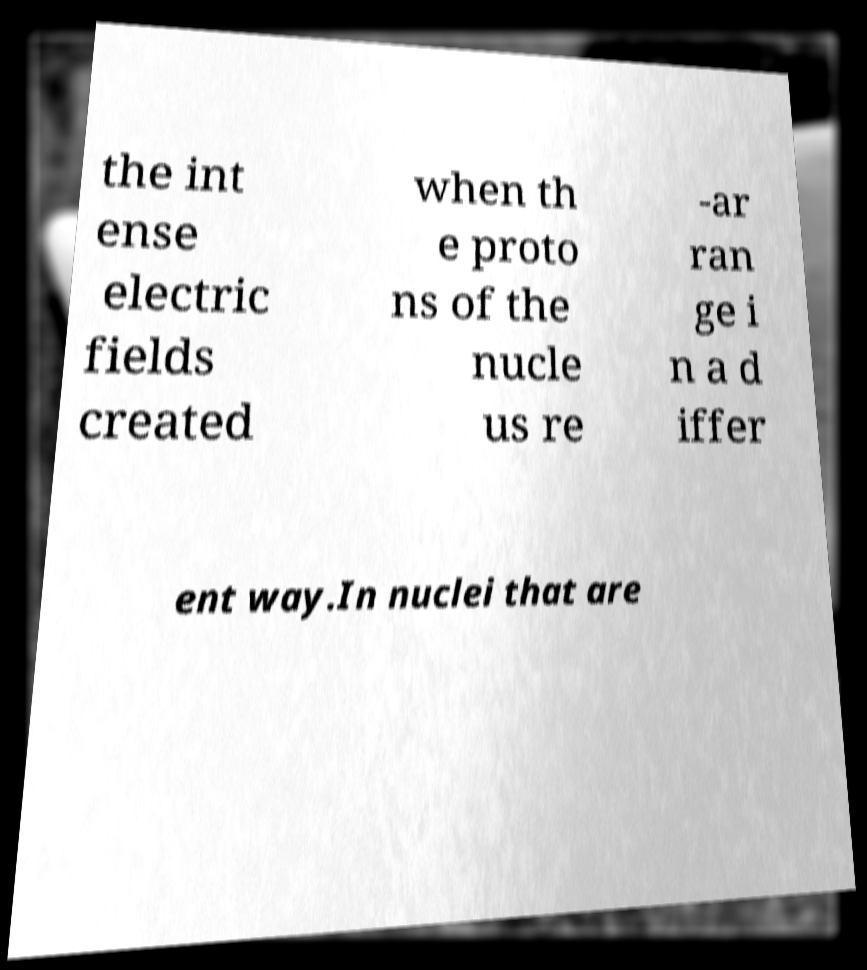Can you read and provide the text displayed in the image?This photo seems to have some interesting text. Can you extract and type it out for me? the int ense electric fields created when th e proto ns of the nucle us re -ar ran ge i n a d iffer ent way.In nuclei that are 